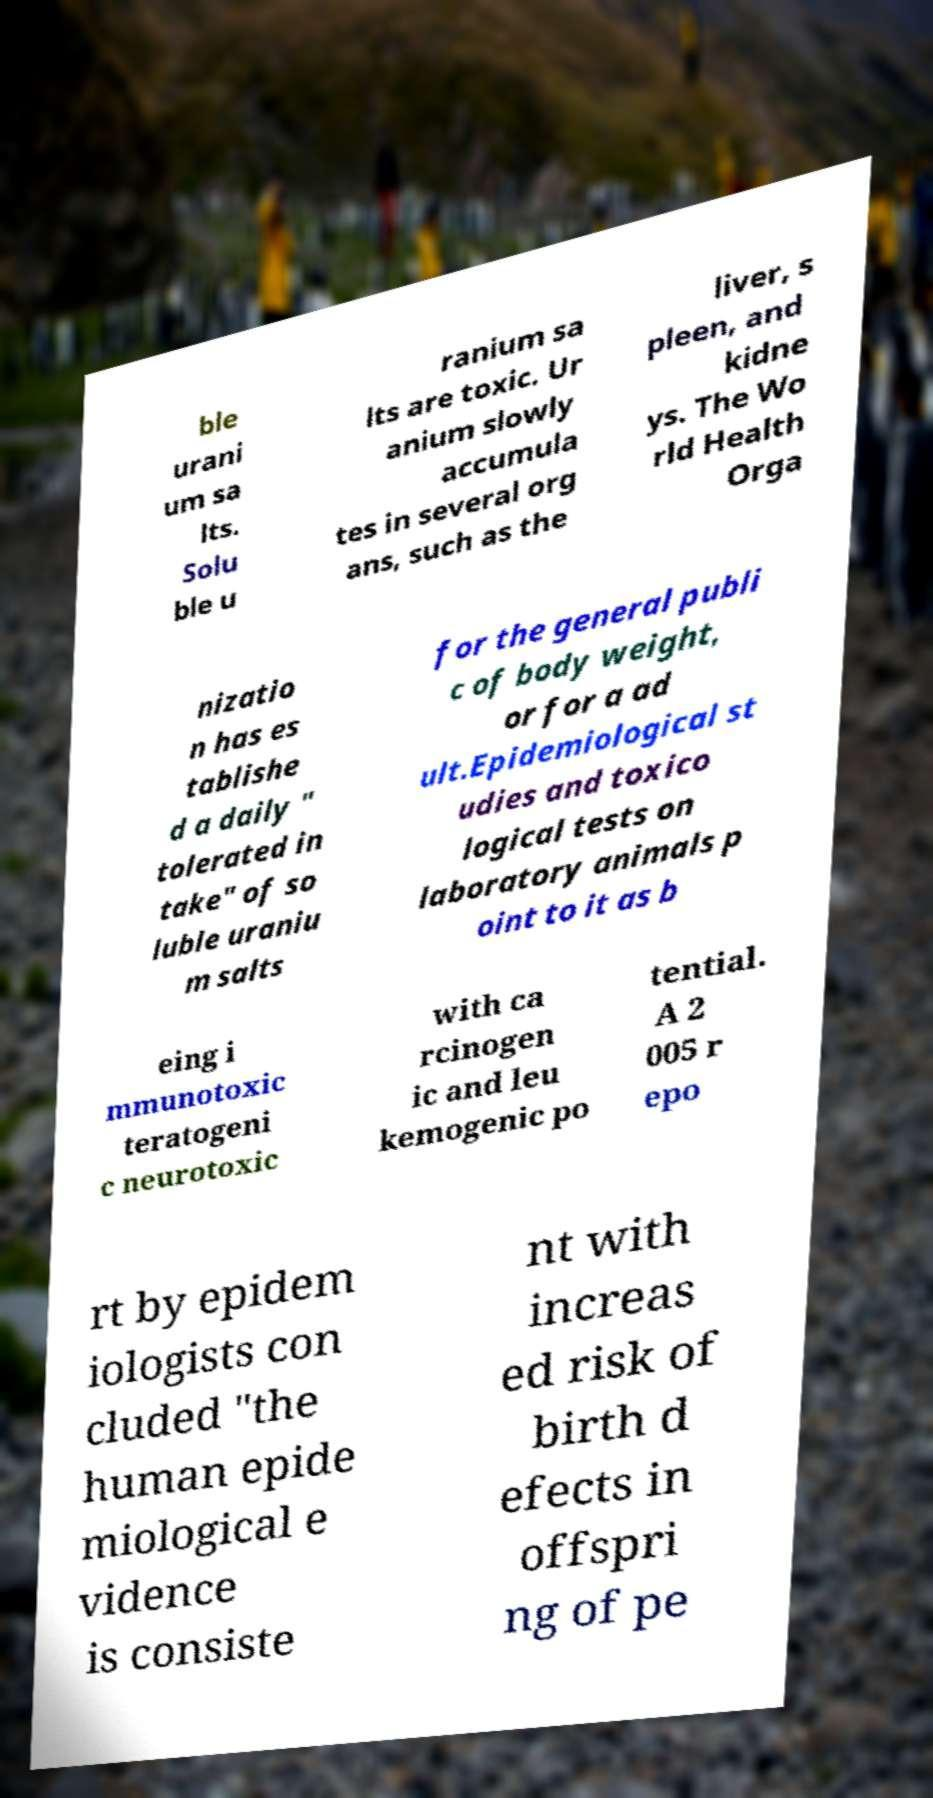Could you extract and type out the text from this image? ble urani um sa lts. Solu ble u ranium sa lts are toxic. Ur anium slowly accumula tes in several org ans, such as the liver, s pleen, and kidne ys. The Wo rld Health Orga nizatio n has es tablishe d a daily " tolerated in take" of so luble uraniu m salts for the general publi c of body weight, or for a ad ult.Epidemiological st udies and toxico logical tests on laboratory animals p oint to it as b eing i mmunotoxic teratogeni c neurotoxic with ca rcinogen ic and leu kemogenic po tential. A 2 005 r epo rt by epidem iologists con cluded "the human epide miological e vidence is consiste nt with increas ed risk of birth d efects in offspri ng of pe 